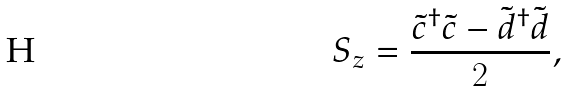<formula> <loc_0><loc_0><loc_500><loc_500>S _ { z } = \frac { \tilde { c } ^ { \dagger } \tilde { c } - \tilde { d } ^ { \dagger } \tilde { d } } { 2 } ,</formula> 